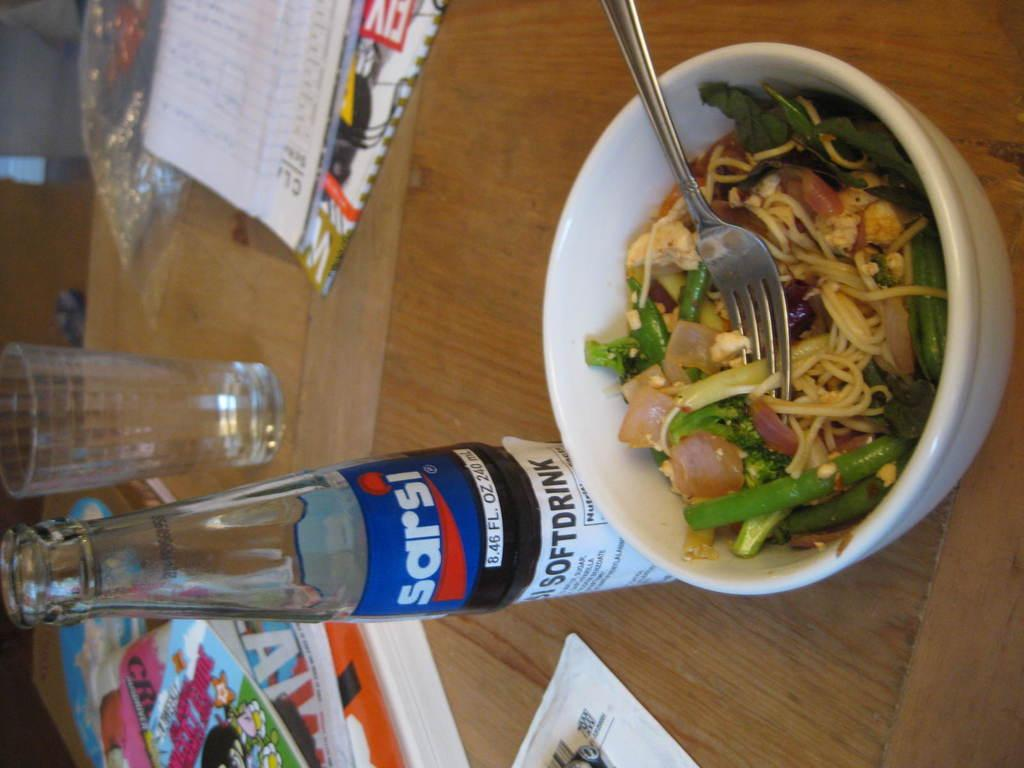<image>
Provide a brief description of the given image. A bowl of salad sits on a table by a Sarsi soft drink. 